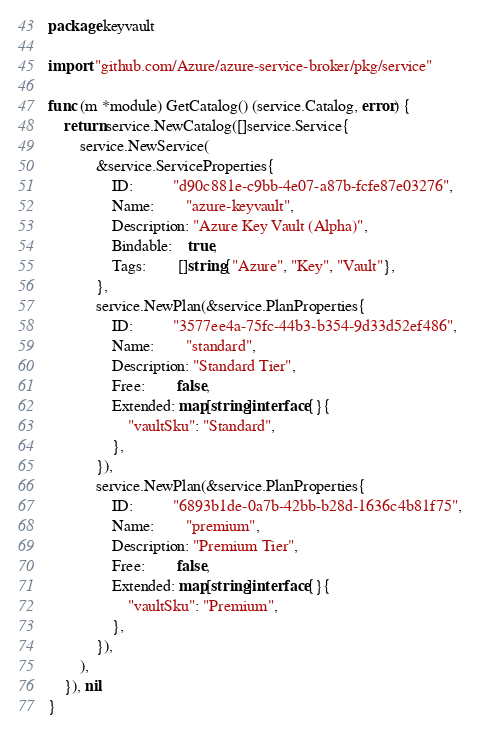Convert code to text. <code><loc_0><loc_0><loc_500><loc_500><_Go_>package keyvault

import "github.com/Azure/azure-service-broker/pkg/service"

func (m *module) GetCatalog() (service.Catalog, error) {
	return service.NewCatalog([]service.Service{
		service.NewService(
			&service.ServiceProperties{
				ID:          "d90c881e-c9bb-4e07-a87b-fcfe87e03276",
				Name:        "azure-keyvault",
				Description: "Azure Key Vault (Alpha)",
				Bindable:    true,
				Tags:        []string{"Azure", "Key", "Vault"},
			},
			service.NewPlan(&service.PlanProperties{
				ID:          "3577ee4a-75fc-44b3-b354-9d33d52ef486",
				Name:        "standard",
				Description: "Standard Tier",
				Free:        false,
				Extended: map[string]interface{}{
					"vaultSku": "Standard",
				},
			}),
			service.NewPlan(&service.PlanProperties{
				ID:          "6893b1de-0a7b-42bb-b28d-1636c4b81f75",
				Name:        "premium",
				Description: "Premium Tier",
				Free:        false,
				Extended: map[string]interface{}{
					"vaultSku": "Premium",
				},
			}),
		),
	}), nil
}
</code> 